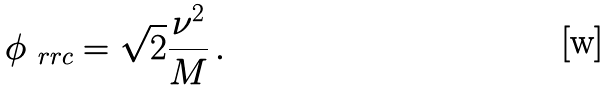Convert formula to latex. <formula><loc_0><loc_0><loc_500><loc_500>\phi _ { \ r r c } = \sqrt { 2 } \frac { \nu ^ { 2 } } { M } \, .</formula> 